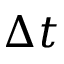<formula> <loc_0><loc_0><loc_500><loc_500>\Delta t</formula> 